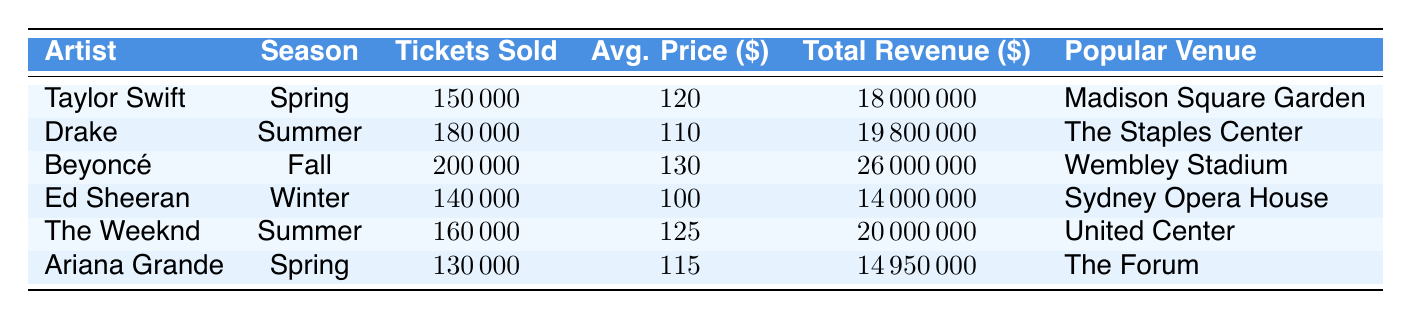What is the total revenue generated by Beyoncé's concerts in the Fall? The table shows that Beyoncé sold 200,000 tickets in the Fall at an average ticket price of $130, generating a total revenue of $26,000,000. Therefore, the answer is directly taken from the 'Total Revenue' column for Beyoncé.
Answer: 26000000 Which artist sold the highest number of tickets in a season? From the table, Beyoncé sold 200,000 tickets during the Fall, which is the highest compared to other artists in different seasons. Other artists have lower ticket sales, so we can confidently conclude that Beyoncé had the highest.
Answer: Beyoncé What is the average ticket price for Drake and The Weeknd's concerts combined? Drake’s average ticket price is $110, and The Weeknd’s average ticket price is $125. The combined average is calculated by summing these prices and dividing by 2: (110 + 125) / 2 = 117.5.
Answer: 117.5 Did Ariana Grande perform in a venue that was as popular as Madison Square Garden? The popular venue for Ariana Grande is The Forum, while Madison Square Garden hosted Taylor Swift. Since Madison Square Garden is a renowned venue, but The Forum may also be popular, this question requires some subjective judgment. Based on common perceptions, Madison Square Garden is often viewed as a more prominent venue than The Forum.
Answer: No What is the total number of tickets sold by artists performing in the Summer? In the Summer, Drake sold 180,000 tickets and The Weeknd sold 160,000. Adding these together gives a total of 180,000 + 160,000 = 340,000 tickets sold in the Summer season.
Answer: 340000 Which season generated the least total revenue? The total revenues are: Taylor Swift in Spring: $18,000,000; Drake in Summer: $19,800,000; Beyoncé in Fall: $26,000,000; Ed Sheeran in Winter: $14,000,000; The Weeknd in Summer: $20,000,000; and Ariana Grande in Spring: $14,950,000. The least revenue is from Ed Sheeran in Winter at $14,000,000.
Answer: Winter How much more revenue did Beyoncé generate than Taylor Swift? Beyoncé generated $26,000,000, while Taylor Swift generated $18,000,000. The difference is calculated as $26,000,000 - $18,000,000 = $8,000,000.
Answer: 8000000 Is the average ticket price for Fall concerts higher than for Winter concerts? Beyoncé's average ticket price in Fall is $130, while Ed Sheeran's average ticket price in Winter is $100. The Fall average is higher than Winter's, so the answer is yes.
Answer: Yes 